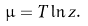Convert formula to latex. <formula><loc_0><loc_0><loc_500><loc_500>\mu = T \ln z .</formula> 